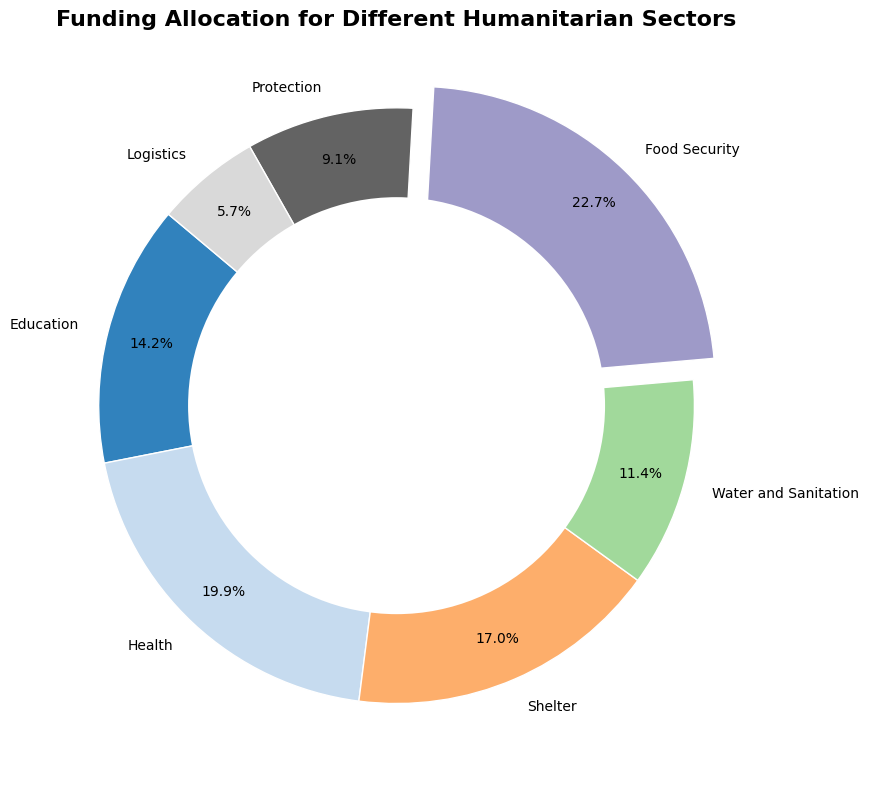What sector receives the highest funding? Look at the pie chart and note which sector's wedge is the largest and has an exploded section.
Answer: Food Security What percentage of the funding is allocated to Education? Find the wedge labeled "Education" and read its percentage directly from the pie chart.
Answer: 15.6% How much more funding does Health receive compared to Protection? Subtract the funding allocation of Protection from that of Health. The values from the table are $1,750,000 for Health and $800,000 for Protection.
Answer: $950,000 Which sectors receive less than 10% of the total funding? Identify the wedges with percentages less than 10%. From the pie chart, the sectors are "Protection" and "Logistics".
Answer: Protection and Logistics Is the funding for Shelter more or less than the funding for Education? Compare the funding allocation amounts of Shelter and Education by looking at the respective wedges. Shelter receives $1,500,000 and Education receives $1,250,000.
Answer: More What is the total funding allocated to Water and Sanitation and Logistics combined? Add the funding allocations for Water and Sanitation ($1,000,000) and Logistics ($500,000).
Answer: $1,500,000 Is the combined funding for Health and Shelter greater than the funding for Food Security? Add the funding allocations for Health ($1,750,000) and Shelter ($1,500,000), and compare the sum ($3,250,000) to Food Security's allocation ($2,000,000).
Answer: Yes Which sectors have funding allocations between 15% and 20%? Identify the wedges with percentages in the range of 15% to 20%. The sectors are "Health", "Shelter", and "Education".
Answer: Health, Shelter, and Education What is the proportion of the total funding allocated to sectors other than Food Security and Health? Subtract the sum of the percentages for Food Security (25.0%) and Health (21.9%) from 100%. The calculation is 100% - 25.0% - 21.9% = 53.1%.
Answer: 53.1% What color is used to represent the Shelter sector in the pie chart? Identify the wedge labeled "Shelter" and note its color.
Answer: Light Blue (or specific color from the chart) 